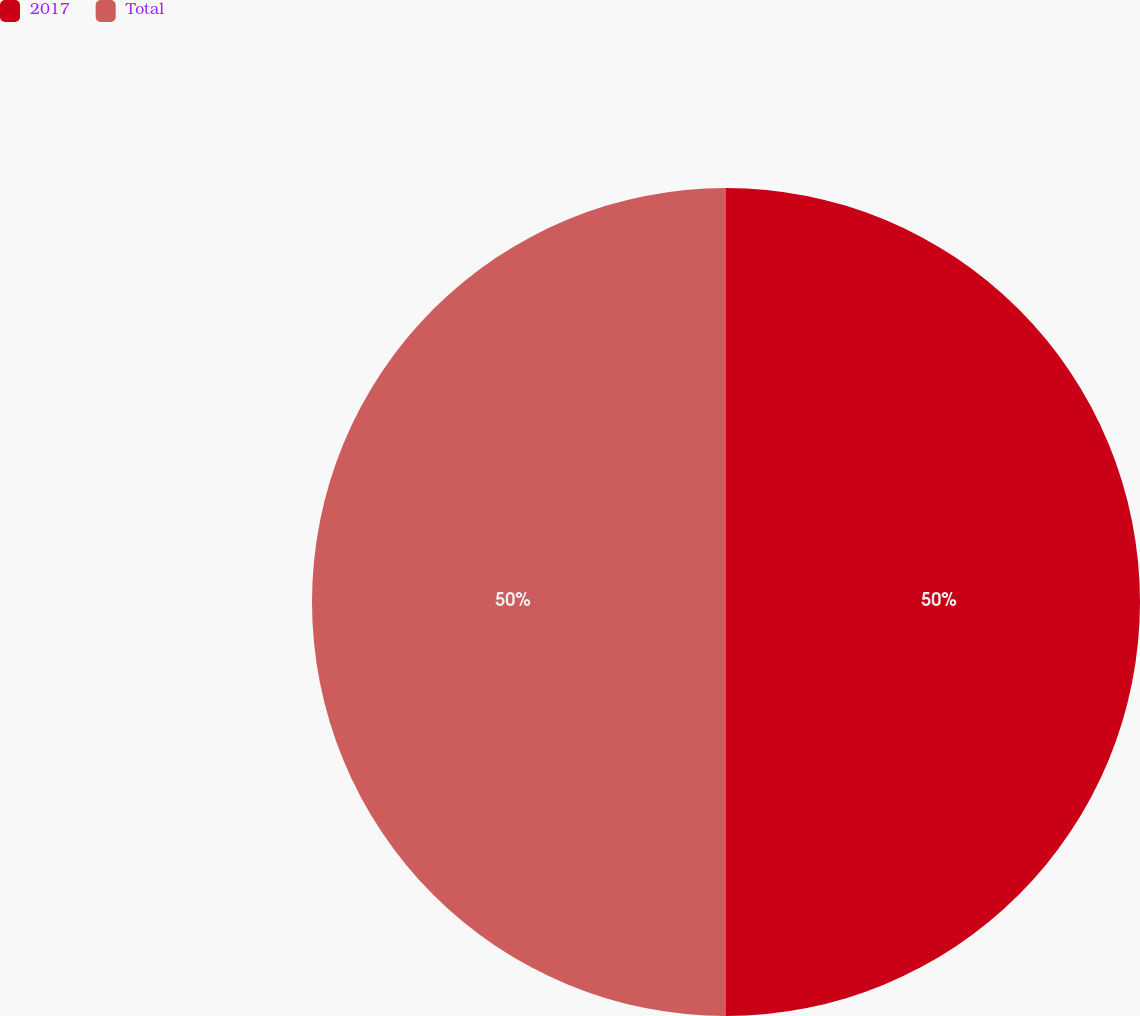Convert chart to OTSL. <chart><loc_0><loc_0><loc_500><loc_500><pie_chart><fcel>2017<fcel>Total<nl><fcel>50.0%<fcel>50.0%<nl></chart> 